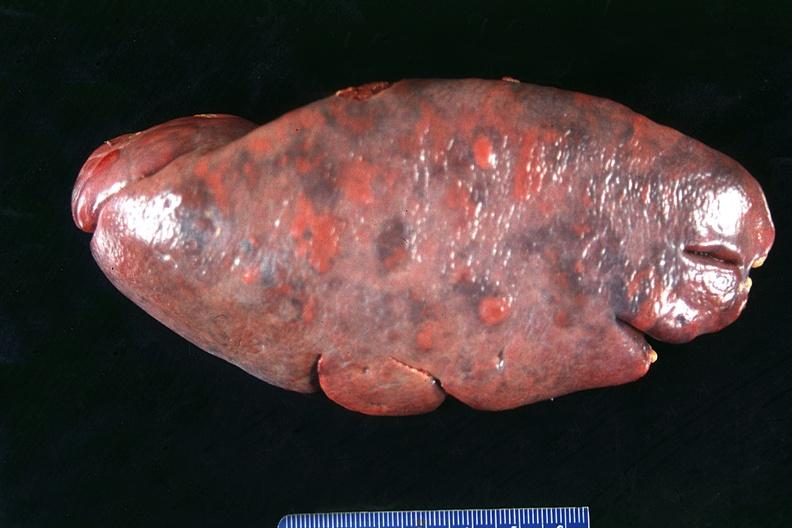where is this part in?
Answer the question using a single word or phrase. Spleen 